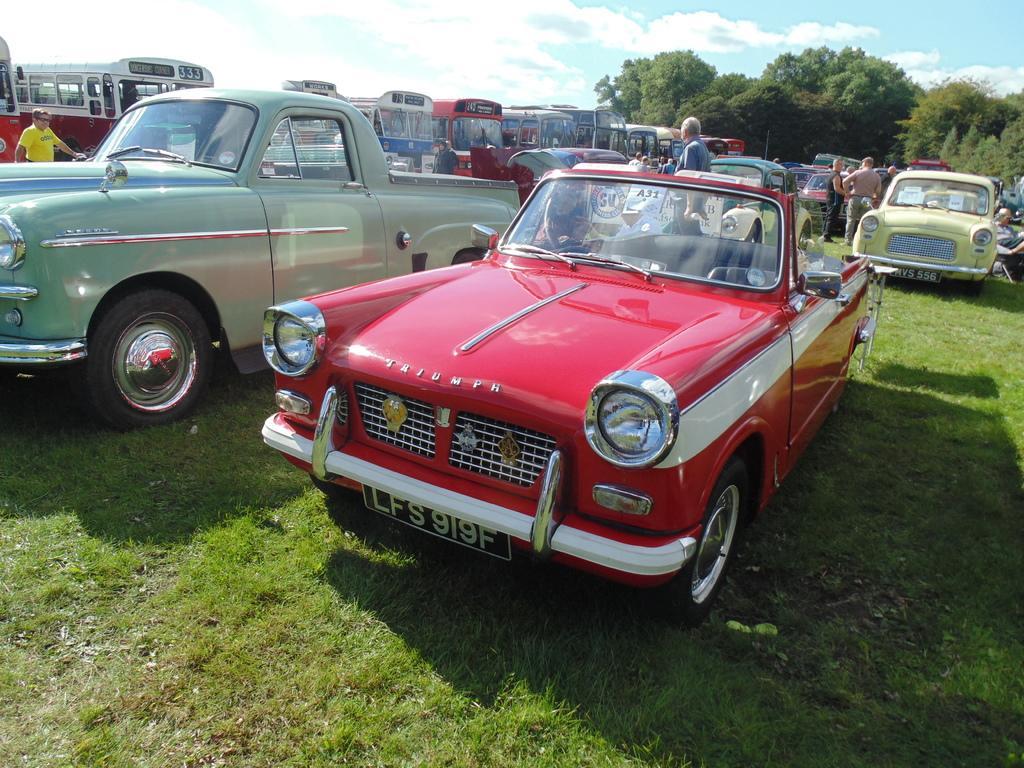Please provide a concise description of this image. In this picture we can see vehicles and people on the ground and in the background we can see trees and the sky. 